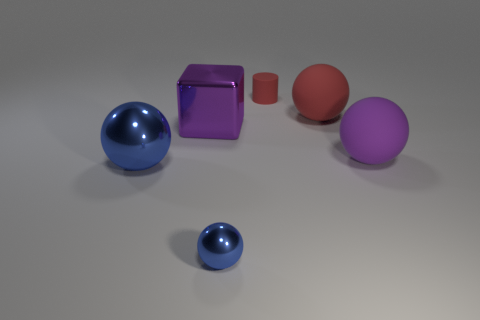What number of yellow things are either large metallic blocks or big matte objects?
Offer a very short reply. 0. What is the color of the small metallic ball?
Offer a terse response. Blue. The red cylinder that is the same material as the big purple ball is what size?
Provide a succinct answer. Small. What number of other things have the same shape as the large purple shiny object?
Provide a succinct answer. 0. There is a blue metallic thing that is to the right of the metal object that is to the left of the large purple block; what is its size?
Your answer should be compact. Small. There is a red object that is the same size as the purple rubber thing; what material is it?
Offer a very short reply. Rubber. Are there any purple objects that have the same material as the large red sphere?
Your response must be concise. Yes. There is a large ball that is in front of the big purple object that is on the right side of the red thing on the right side of the red matte cylinder; what color is it?
Offer a very short reply. Blue. There is a large sphere behind the metallic cube; is its color the same as the small thing that is behind the big shiny block?
Make the answer very short. Yes. Are there fewer things that are in front of the cylinder than big blue shiny balls?
Offer a terse response. No. 